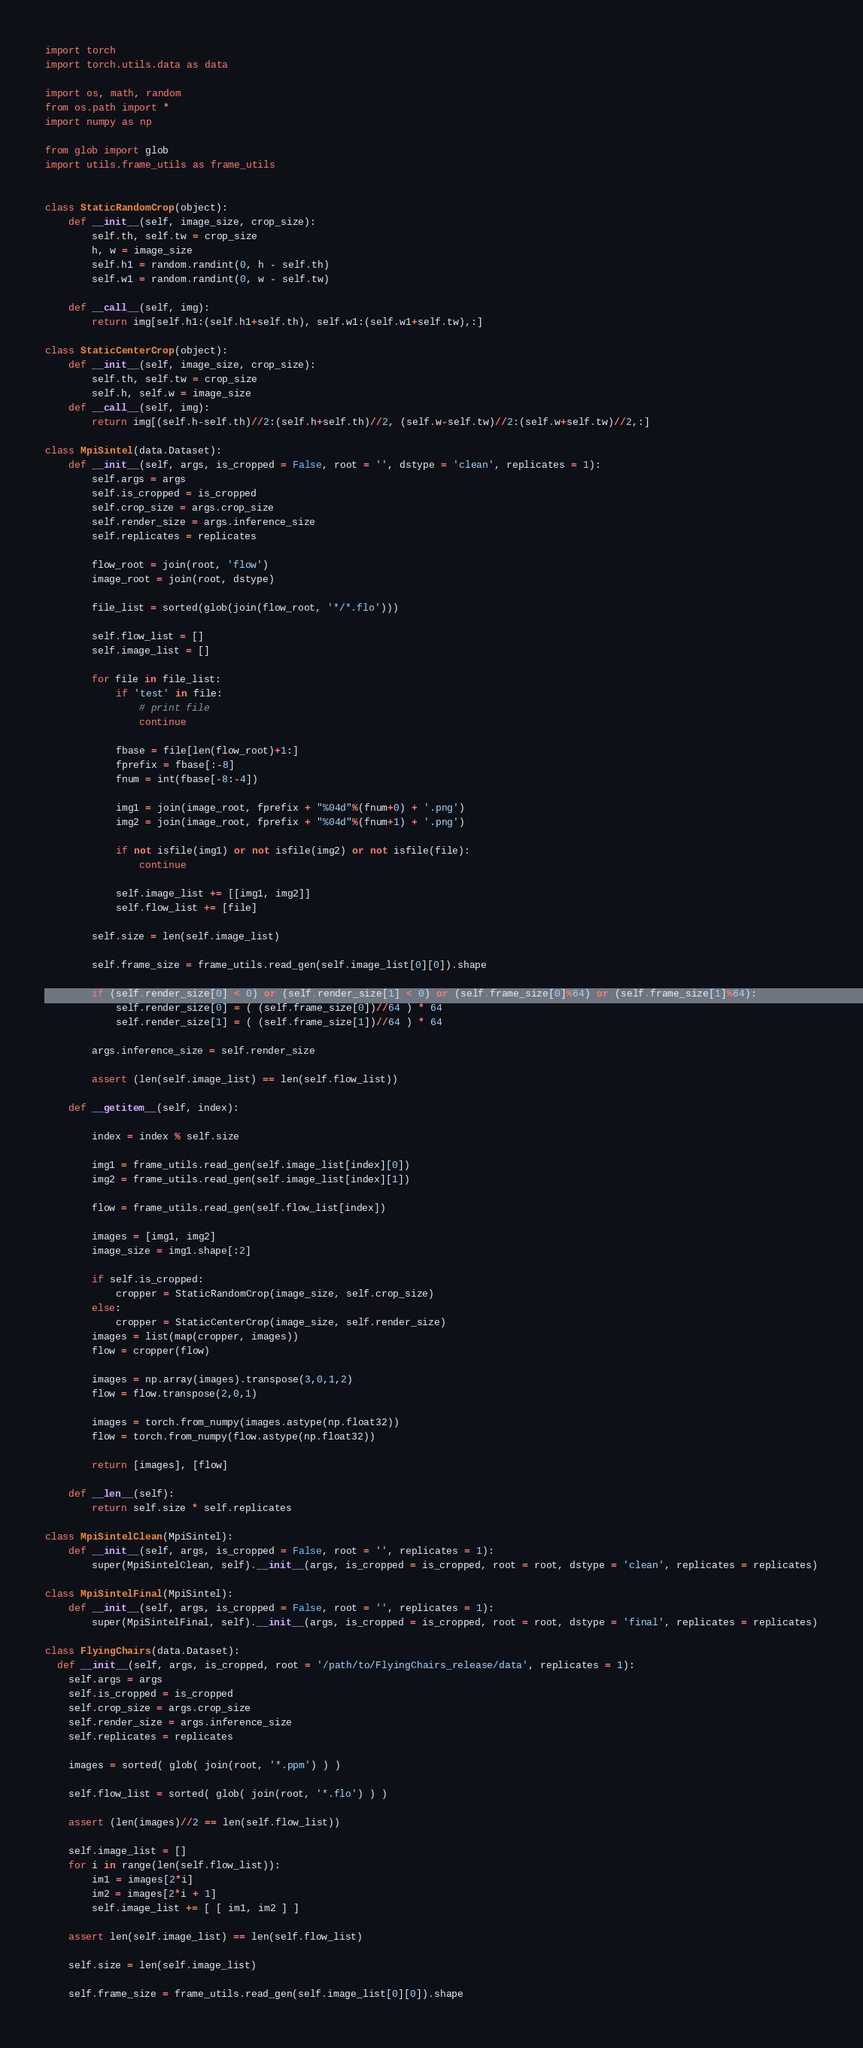<code> <loc_0><loc_0><loc_500><loc_500><_Python_>import torch
import torch.utils.data as data

import os, math, random
from os.path import *
import numpy as np

from glob import glob
import utils.frame_utils as frame_utils


class StaticRandomCrop(object):
    def __init__(self, image_size, crop_size):
        self.th, self.tw = crop_size
        h, w = image_size
        self.h1 = random.randint(0, h - self.th)
        self.w1 = random.randint(0, w - self.tw)

    def __call__(self, img):
        return img[self.h1:(self.h1+self.th), self.w1:(self.w1+self.tw),:]

class StaticCenterCrop(object):
    def __init__(self, image_size, crop_size):
        self.th, self.tw = crop_size
        self.h, self.w = image_size
    def __call__(self, img):
        return img[(self.h-self.th)//2:(self.h+self.th)//2, (self.w-self.tw)//2:(self.w+self.tw)//2,:]

class MpiSintel(data.Dataset):
    def __init__(self, args, is_cropped = False, root = '', dstype = 'clean', replicates = 1):
        self.args = args
        self.is_cropped = is_cropped
        self.crop_size = args.crop_size
        self.render_size = args.inference_size
        self.replicates = replicates

        flow_root = join(root, 'flow')
        image_root = join(root, dstype)

        file_list = sorted(glob(join(flow_root, '*/*.flo')))

        self.flow_list = []
        self.image_list = []

        for file in file_list:
            if 'test' in file:
                # print file
                continue

            fbase = file[len(flow_root)+1:]
            fprefix = fbase[:-8]
            fnum = int(fbase[-8:-4])

            img1 = join(image_root, fprefix + "%04d"%(fnum+0) + '.png')
            img2 = join(image_root, fprefix + "%04d"%(fnum+1) + '.png')

            if not isfile(img1) or not isfile(img2) or not isfile(file):
                continue

            self.image_list += [[img1, img2]]
            self.flow_list += [file]

        self.size = len(self.image_list)

        self.frame_size = frame_utils.read_gen(self.image_list[0][0]).shape

        if (self.render_size[0] < 0) or (self.render_size[1] < 0) or (self.frame_size[0]%64) or (self.frame_size[1]%64):
            self.render_size[0] = ( (self.frame_size[0])//64 ) * 64
            self.render_size[1] = ( (self.frame_size[1])//64 ) * 64

        args.inference_size = self.render_size

        assert (len(self.image_list) == len(self.flow_list))

    def __getitem__(self, index):

        index = index % self.size

        img1 = frame_utils.read_gen(self.image_list[index][0])
        img2 = frame_utils.read_gen(self.image_list[index][1])

        flow = frame_utils.read_gen(self.flow_list[index])

        images = [img1, img2]
        image_size = img1.shape[:2]

        if self.is_cropped:
            cropper = StaticRandomCrop(image_size, self.crop_size)
        else:
            cropper = StaticCenterCrop(image_size, self.render_size)
        images = list(map(cropper, images))
        flow = cropper(flow)

        images = np.array(images).transpose(3,0,1,2)
        flow = flow.transpose(2,0,1)

        images = torch.from_numpy(images.astype(np.float32))
        flow = torch.from_numpy(flow.astype(np.float32))

        return [images], [flow]

    def __len__(self):
        return self.size * self.replicates

class MpiSintelClean(MpiSintel):
    def __init__(self, args, is_cropped = False, root = '', replicates = 1):
        super(MpiSintelClean, self).__init__(args, is_cropped = is_cropped, root = root, dstype = 'clean', replicates = replicates)

class MpiSintelFinal(MpiSintel):
    def __init__(self, args, is_cropped = False, root = '', replicates = 1):
        super(MpiSintelFinal, self).__init__(args, is_cropped = is_cropped, root = root, dstype = 'final', replicates = replicates)

class FlyingChairs(data.Dataset):
  def __init__(self, args, is_cropped, root = '/path/to/FlyingChairs_release/data', replicates = 1):
    self.args = args
    self.is_cropped = is_cropped
    self.crop_size = args.crop_size
    self.render_size = args.inference_size
    self.replicates = replicates

    images = sorted( glob( join(root, '*.ppm') ) )

    self.flow_list = sorted( glob( join(root, '*.flo') ) )

    assert (len(images)//2 == len(self.flow_list))

    self.image_list = []
    for i in range(len(self.flow_list)):
        im1 = images[2*i]
        im2 = images[2*i + 1]
        self.image_list += [ [ im1, im2 ] ]

    assert len(self.image_list) == len(self.flow_list)

    self.size = len(self.image_list)

    self.frame_size = frame_utils.read_gen(self.image_list[0][0]).shape
</code> 